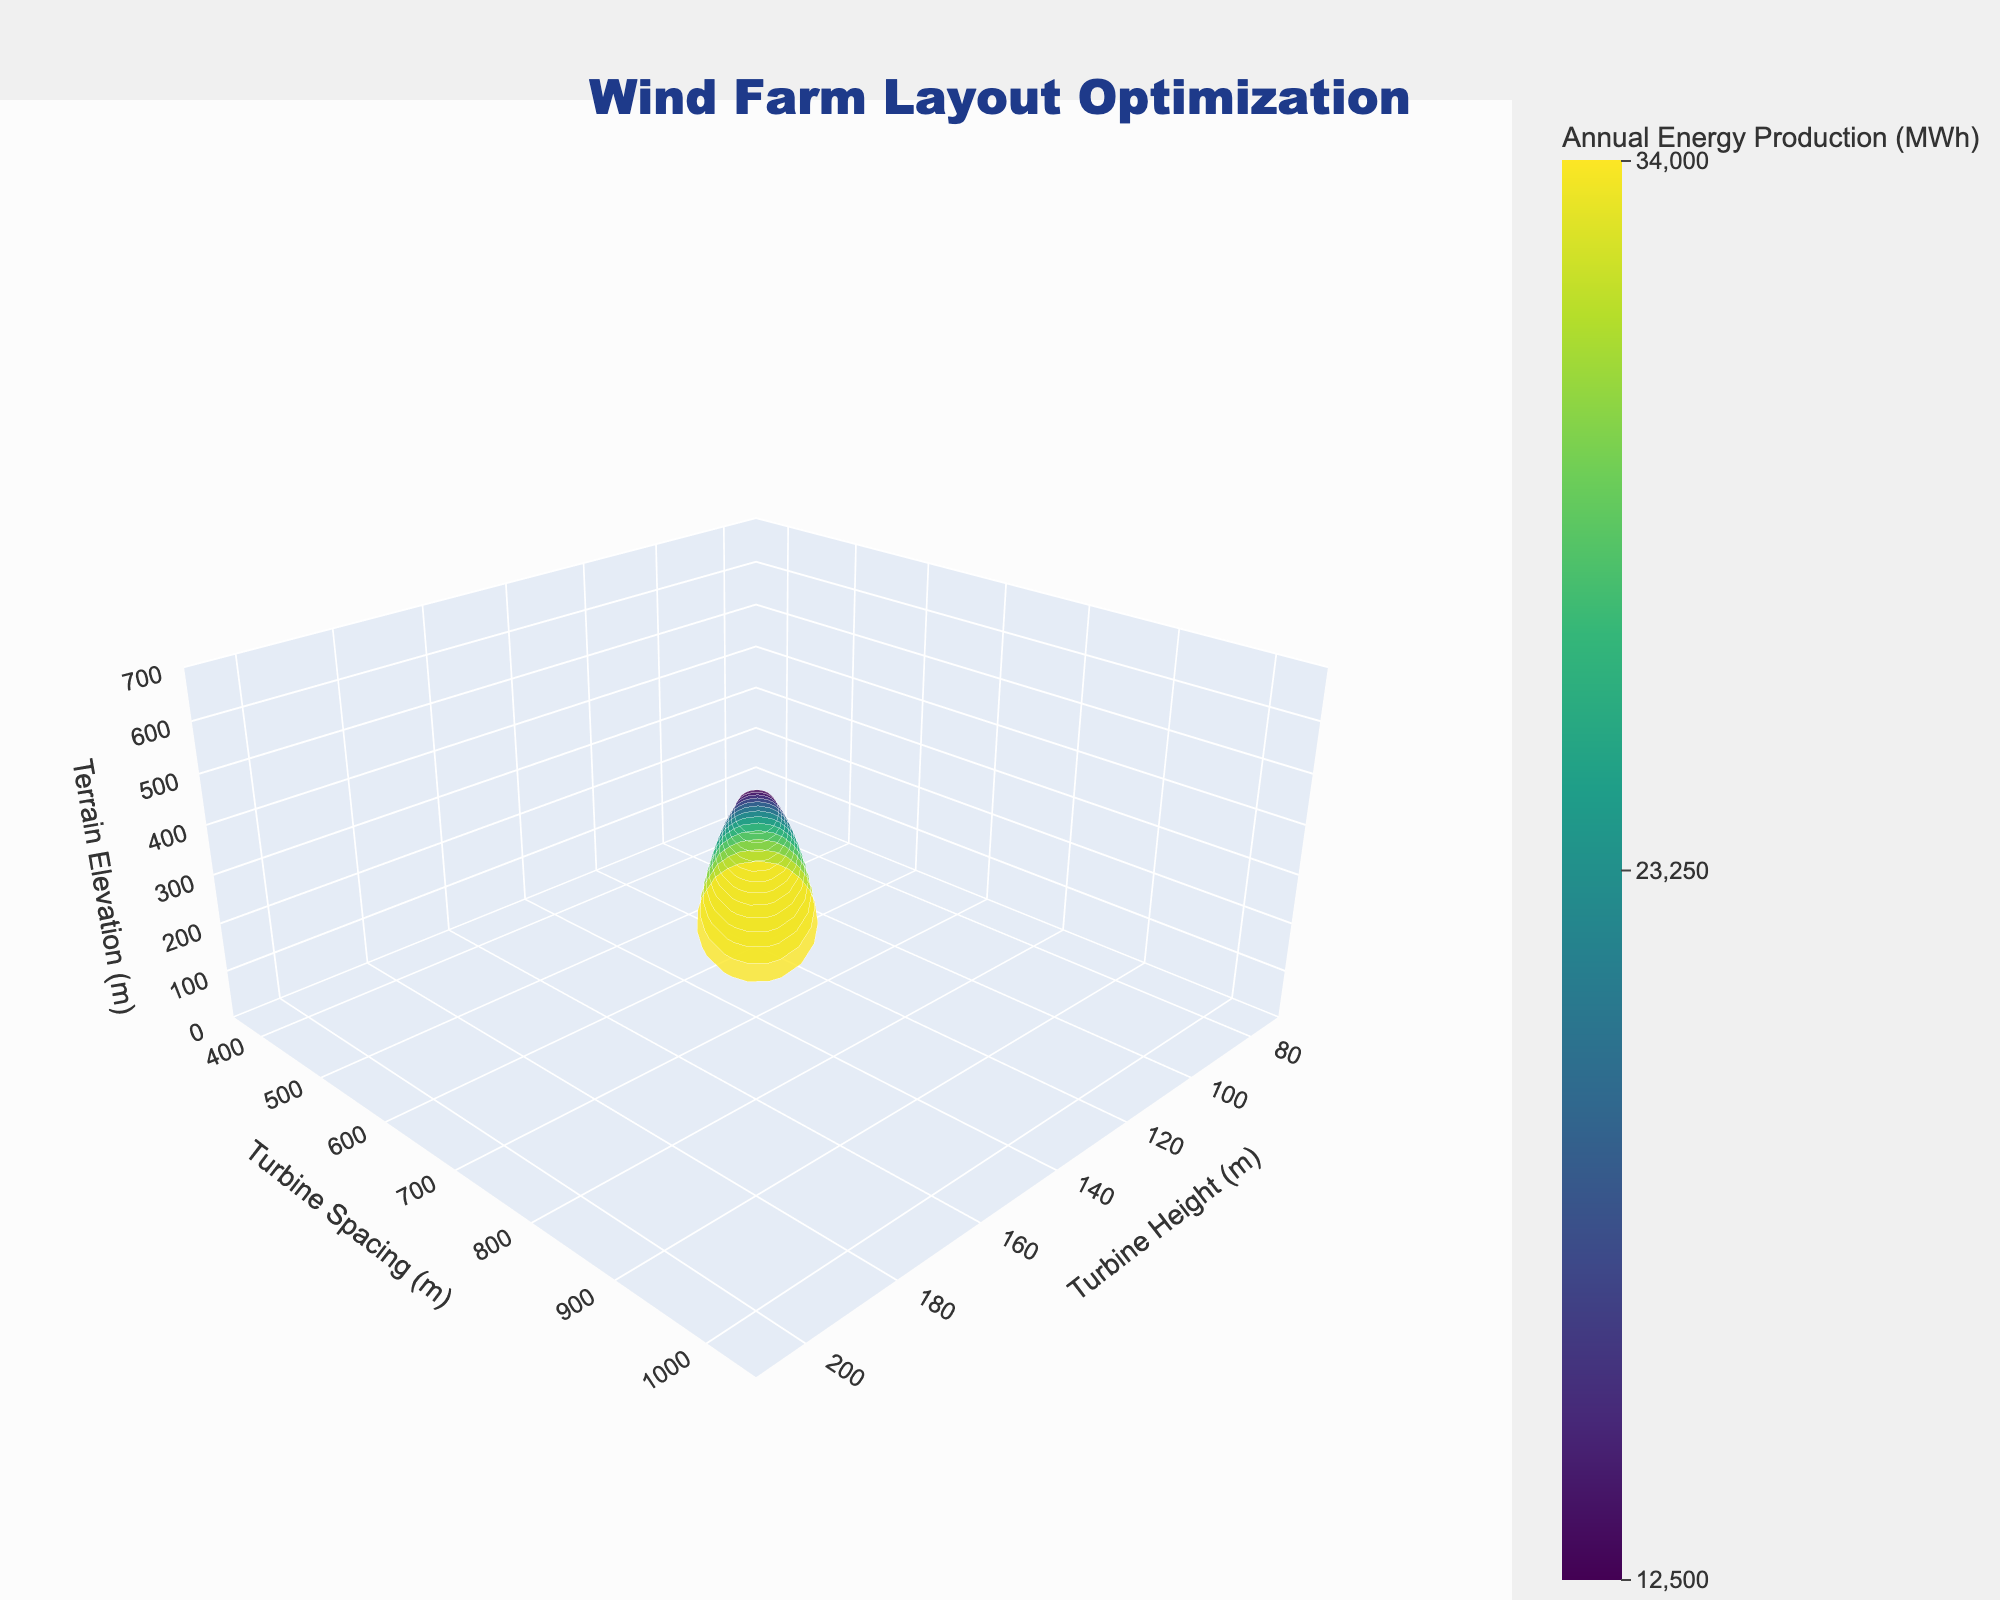What's the title of the plot? The plot title is given at the top in a large blue font. It reads, "Wind Farm Layout Optimization".
Answer: Wind Farm Layout Optimization What are the axes titles? The axis titles can be found along each axis of the 3D plot. They are "Turbine Height (m)", "Turbine Spacing (m)", and "Terrain Elevation (m)".
Answer: Turbine Height (m), Turbine Spacing (m), Terrain Elevation (m) How many data points are plotted in the 3D scatter plot? By counting the number of markers shown in the plot, we can see that there are 13 data points, corresponding to the 13 rows of the provided data.
Answer: 13 Which turbine height corresponds to the highest annual energy production? The highest annual energy production of 34,000 MWh is represented by the largest marker. By looking at the x-axis (Turbine Height), the marker lies at 200 meters.
Answer: 200 meters For a turbine height of 100 meters, what's the annual energy production? Locate the data point on the x-axis at 100 meters. The marker size and color indicate energy production, and hovering over or checking data reveals it is 16,000 MWh.
Answer: 16,000 MWh Compare the annual energy production for turbine heights of 150m and 180m. Which produces more energy? Look at the markers at 150 meters and 180 meters. The marker at 180 meters is larger and has a higher MWh value of 30,400 compared to 25,000 MWh at 150 meters.
Answer: 180 meters What’s the average turbine spacing for turbines with annual energy production equal to or above 25,000 MWh? Identify data points with annual energy production of 25,000 MWh or more: heights at 150m, 160m, 170m, 180m, 190m, and 200m. Their spacings are 750m, 800m, 850m, 900m, 950m, and 1000m. The average is (750 + 800 + 850 + 900 + 950 + 1000) / 6 = 875m.
Answer: 875 meters How does terrain elevation impact annual energy production for a turbine height of 130 meters? Check the data point at 130 meters height. The terrain elevation is 300 meters with an energy production of 21,400 MWh. As elevation increases, energy production also increases.
Answer: Higher terrain elevation positively impacts annual energy production 